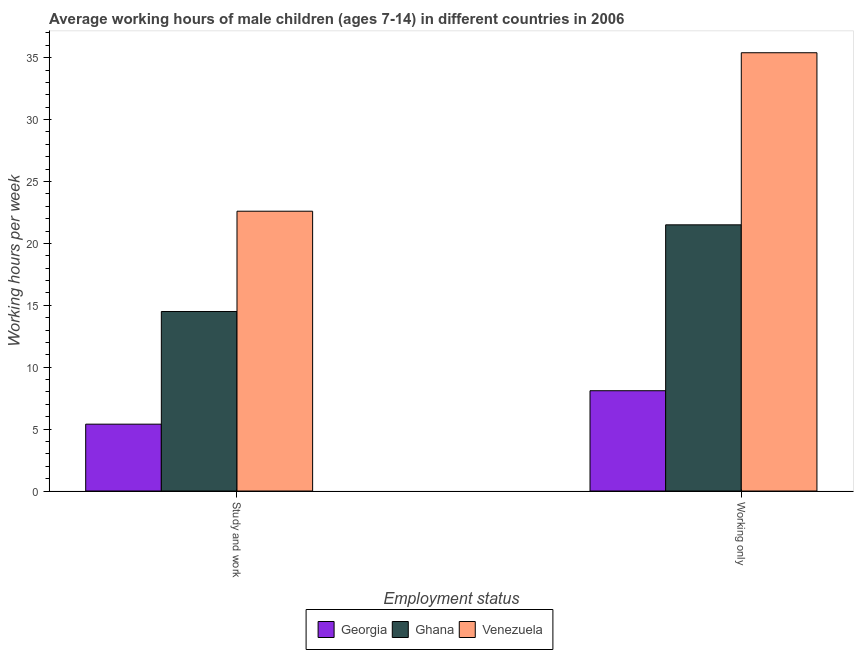How many groups of bars are there?
Your response must be concise. 2. How many bars are there on the 1st tick from the left?
Provide a short and direct response. 3. What is the label of the 1st group of bars from the left?
Your answer should be very brief. Study and work. Across all countries, what is the maximum average working hour of children involved in only work?
Ensure brevity in your answer.  35.4. Across all countries, what is the minimum average working hour of children involved in only work?
Your answer should be very brief. 8.1. In which country was the average working hour of children involved in only work maximum?
Your answer should be compact. Venezuela. In which country was the average working hour of children involved in only work minimum?
Ensure brevity in your answer.  Georgia. What is the total average working hour of children involved in study and work in the graph?
Make the answer very short. 42.5. What is the difference between the average working hour of children involved in only work in Georgia and that in Venezuela?
Provide a short and direct response. -27.3. What is the difference between the average working hour of children involved in study and work in Venezuela and the average working hour of children involved in only work in Ghana?
Offer a terse response. 1.1. What is the average average working hour of children involved in only work per country?
Give a very brief answer. 21.67. What is the ratio of the average working hour of children involved in only work in Ghana to that in Georgia?
Your response must be concise. 2.65. What does the 3rd bar from the left in Working only represents?
Provide a succinct answer. Venezuela. What does the 3rd bar from the right in Working only represents?
Offer a very short reply. Georgia. How many countries are there in the graph?
Make the answer very short. 3. What is the difference between two consecutive major ticks on the Y-axis?
Offer a very short reply. 5. Are the values on the major ticks of Y-axis written in scientific E-notation?
Provide a short and direct response. No. Where does the legend appear in the graph?
Provide a short and direct response. Bottom center. How many legend labels are there?
Provide a short and direct response. 3. How are the legend labels stacked?
Your answer should be very brief. Horizontal. What is the title of the graph?
Your answer should be compact. Average working hours of male children (ages 7-14) in different countries in 2006. Does "Vietnam" appear as one of the legend labels in the graph?
Offer a terse response. No. What is the label or title of the X-axis?
Make the answer very short. Employment status. What is the label or title of the Y-axis?
Provide a short and direct response. Working hours per week. What is the Working hours per week of Venezuela in Study and work?
Your answer should be compact. 22.6. What is the Working hours per week in Georgia in Working only?
Your answer should be very brief. 8.1. What is the Working hours per week of Venezuela in Working only?
Provide a short and direct response. 35.4. Across all Employment status, what is the maximum Working hours per week of Georgia?
Ensure brevity in your answer.  8.1. Across all Employment status, what is the maximum Working hours per week of Ghana?
Offer a very short reply. 21.5. Across all Employment status, what is the maximum Working hours per week in Venezuela?
Provide a succinct answer. 35.4. Across all Employment status, what is the minimum Working hours per week in Venezuela?
Your answer should be compact. 22.6. What is the total Working hours per week in Venezuela in the graph?
Your answer should be compact. 58. What is the difference between the Working hours per week in Georgia in Study and work and that in Working only?
Your response must be concise. -2.7. What is the difference between the Working hours per week of Ghana in Study and work and that in Working only?
Offer a very short reply. -7. What is the difference between the Working hours per week of Georgia in Study and work and the Working hours per week of Ghana in Working only?
Your answer should be very brief. -16.1. What is the difference between the Working hours per week in Georgia in Study and work and the Working hours per week in Venezuela in Working only?
Offer a terse response. -30. What is the difference between the Working hours per week in Ghana in Study and work and the Working hours per week in Venezuela in Working only?
Offer a terse response. -20.9. What is the average Working hours per week in Georgia per Employment status?
Keep it short and to the point. 6.75. What is the average Working hours per week of Ghana per Employment status?
Provide a short and direct response. 18. What is the difference between the Working hours per week in Georgia and Working hours per week in Venezuela in Study and work?
Provide a short and direct response. -17.2. What is the difference between the Working hours per week of Georgia and Working hours per week of Venezuela in Working only?
Offer a terse response. -27.3. What is the difference between the Working hours per week in Ghana and Working hours per week in Venezuela in Working only?
Provide a succinct answer. -13.9. What is the ratio of the Working hours per week in Georgia in Study and work to that in Working only?
Your answer should be compact. 0.67. What is the ratio of the Working hours per week in Ghana in Study and work to that in Working only?
Your response must be concise. 0.67. What is the ratio of the Working hours per week of Venezuela in Study and work to that in Working only?
Ensure brevity in your answer.  0.64. What is the difference between the highest and the second highest Working hours per week of Georgia?
Your answer should be very brief. 2.7. What is the difference between the highest and the second highest Working hours per week in Ghana?
Provide a short and direct response. 7. What is the difference between the highest and the lowest Working hours per week in Venezuela?
Offer a terse response. 12.8. 